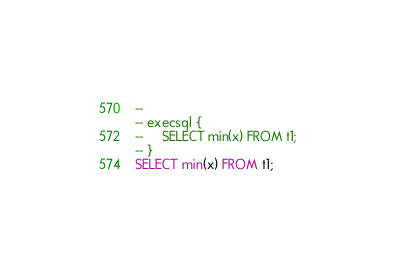Convert code to text. <code><loc_0><loc_0><loc_500><loc_500><_SQL_>-- 
-- execsql {
--     SELECT min(x) FROM t1;
-- }
SELECT min(x) FROM t1;</code> 